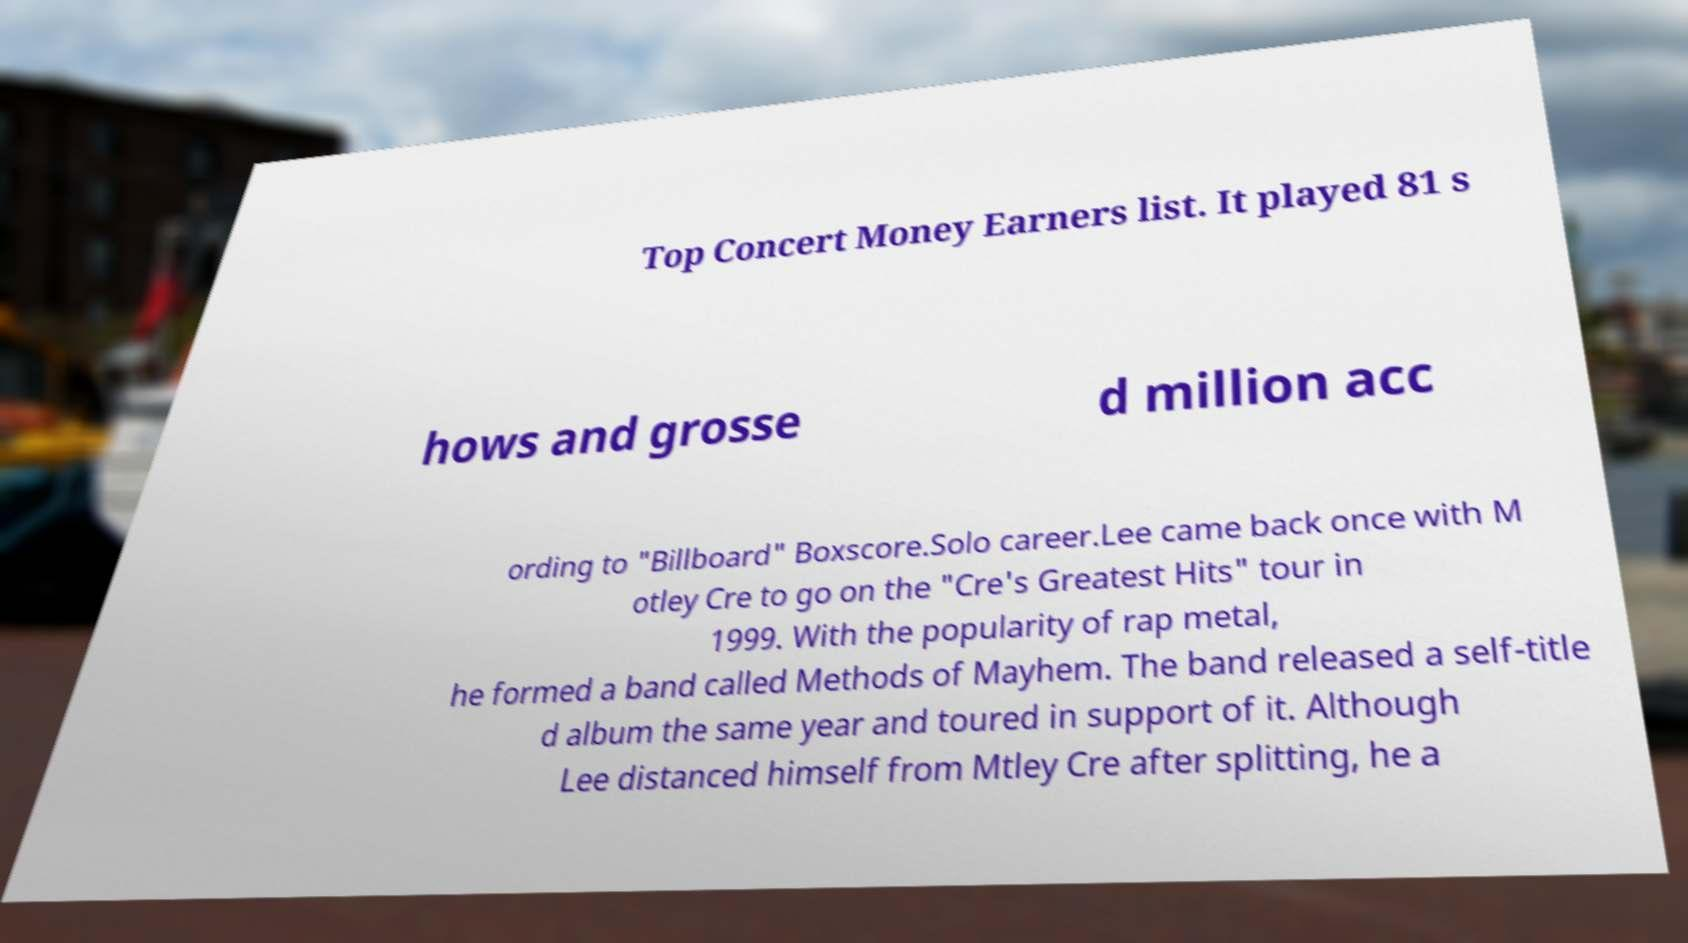Can you read and provide the text displayed in the image?This photo seems to have some interesting text. Can you extract and type it out for me? Top Concert Money Earners list. It played 81 s hows and grosse d million acc ording to "Billboard" Boxscore.Solo career.Lee came back once with M otley Cre to go on the "Cre's Greatest Hits" tour in 1999. With the popularity of rap metal, he formed a band called Methods of Mayhem. The band released a self-title d album the same year and toured in support of it. Although Lee distanced himself from Mtley Cre after splitting, he a 